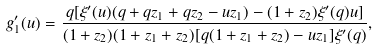Convert formula to latex. <formula><loc_0><loc_0><loc_500><loc_500>g _ { 1 } ^ { \prime } ( u ) = \frac { q [ \xi ^ { \prime } ( u ) ( q + q z _ { 1 } + q z _ { 2 } - u z _ { 1 } ) - ( 1 + z _ { 2 } ) \xi ^ { \prime } ( q ) u ] } { ( 1 + z _ { 2 } ) ( 1 + z _ { 1 } + z _ { 2 } ) [ q ( 1 + z _ { 1 } + z _ { 2 } ) - u z _ { 1 } ] \xi ^ { \prime } ( q ) } ,</formula> 